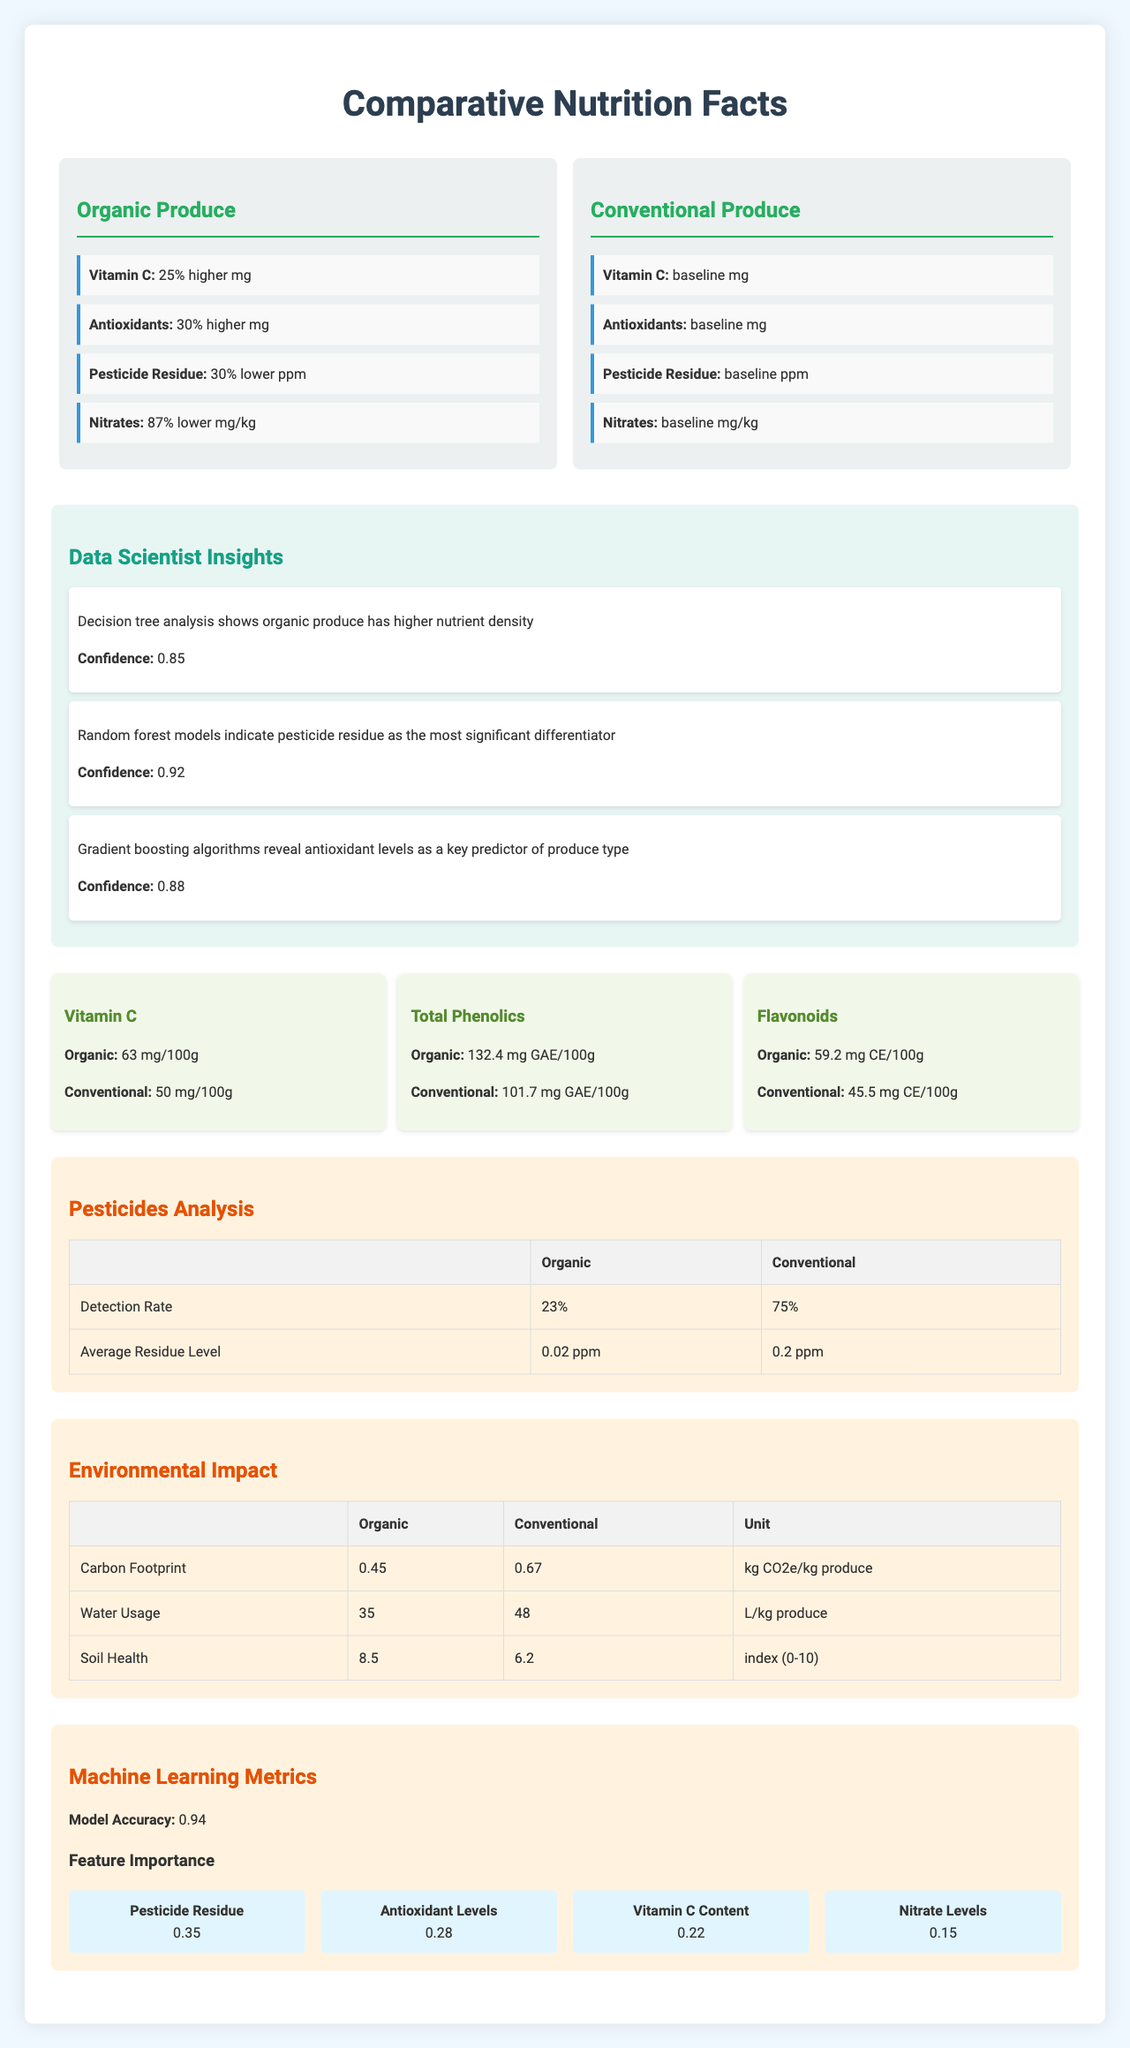What is the average Vitamin C content in organic produce? The nutrient comparison section shows that the average Vitamin C content in organic produce is 63 mg/100g.
Answer: 63 mg/100g What is the main difference in environmental impact between organic and conventional produce? The environmental impact section shows differences in carbon footprint, water usage, and soil health between organic and conventional produce.
Answer: Carbon Footprint, Water Usage, Soil Health What is the detection rate of pesticide residue in conventional produce? The pesticides analysis section indicates that the detection rate of pesticide residue in conventional produce is 75%.
Answer: 75% How much higher are antioxidant levels in organic produce compared to conventional produce? The tree structure for Organic Produce shows that antioxidants are 30% higher in organic produce compared to conventional produce.
Answer: 30% higher What algorithm revealed antioxidant levels as a key predictor of produce type? The data scientist insights section notes that gradient boosting algorithms reveal antioxidant levels as a key predictor of produce type.
Answer: Gradient boosting algorithms Which feature is considered the most important according to the machine learning metrics? A. Vitamin C Content B. Antioxidant Levels C. Pesticide Residue D. Nitrate Levels The machine learning metrics section states that pesticide residue is the most important feature with an importance of 0.35.
Answer: C. Pesticide Residue Which of the following nutrients has the highest average content in organic produce compared to conventional produce? I. Vitamin C II. Total Phenolics III. Flavonoids The nutrient comparison section shows that the average total phenolics content in organic produce is 132.4 mg GAE/100g, which is higher compared to Vitamin C and Flavonoids.
Answer: II. Total Phenolics Can the specific pesticide types detected be determined from this document? The document provides the detection rate and average residue level of pesticide residue, but does not specify the types of pesticides detected.
Answer: Cannot be determined Does organic produce have a lower carbon footprint compared to conventional produce? The environmental impact section shows that organic produce has a lower carbon footprint (0.45 kg CO2e/kg produce) compared to conventional produce (0.67 kg CO2e/kg produce).
Answer: Yes Summarize the main findings of the document. The document provides a comprehensive comparison between organic and conventional produce in terms of nutrition, pesticide residues, and environmental impacts. Organic produce generally has higher levels of vitamins and antioxidants, lower pesticide residues, and better environmental metrics. Data science insights support these observations with strong confidence, emphasizing pesticide residue as a key differentiator.
Answer: The document compares the nutritional content, pesticide residue levels, and environmental impact of organic versus conventional produce. It includes a tree structure showing differences in nutrients such as Vitamin C and antioxidants, pesticide residues, and nitrates. Insights from data science analyses highlight that organic produce generally has higher nutrient density and lower pesticide residues, with pesticide residue being a significant differentiator. Nutrient comparisons and environmental impacts are also detailed, and machine learning metrics indicate the importance of various features. 